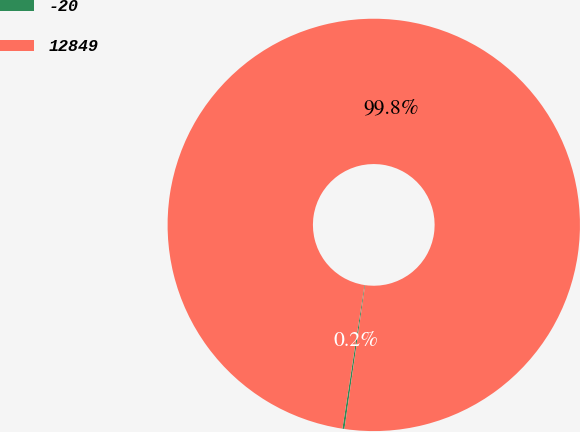<chart> <loc_0><loc_0><loc_500><loc_500><pie_chart><fcel>-20<fcel>12849<nl><fcel>0.16%<fcel>99.84%<nl></chart> 